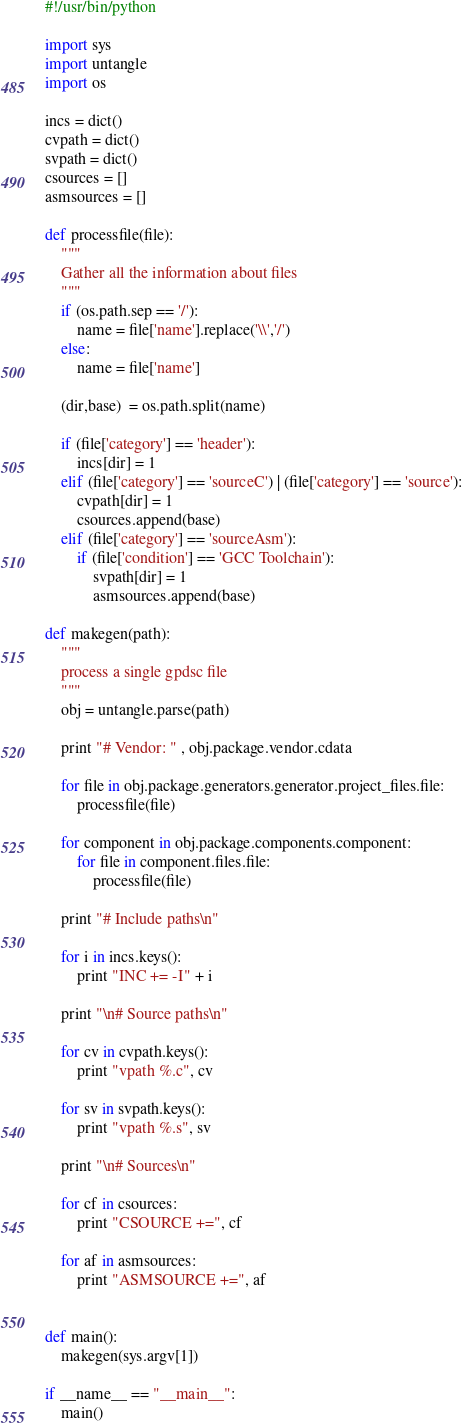Convert code to text. <code><loc_0><loc_0><loc_500><loc_500><_Python_>#!/usr/bin/python

import sys
import untangle
import os

incs = dict()
cvpath = dict()
svpath = dict()
csources = []
asmsources = []

def processfile(file):
    """
    Gather all the information about files
    """
    if (os.path.sep == '/'):
        name = file['name'].replace('\\','/')
    else:
        name = file['name']

    (dir,base)  = os.path.split(name)
    
    if (file['category'] == 'header'):
        incs[dir] = 1
    elif (file['category'] == 'sourceC') | (file['category'] == 'source'):
        cvpath[dir] = 1
        csources.append(base)
    elif (file['category'] == 'sourceAsm'):
        if (file['condition'] == 'GCC Toolchain'):
            svpath[dir] = 1
            asmsources.append(base)

def makegen(path):
    """
    process a single gpdsc file
    """
    obj = untangle.parse(path)

    print "# Vendor: " , obj.package.vendor.cdata

    for file in obj.package.generators.generator.project_files.file:
        processfile(file)

    for component in obj.package.components.component:
        for file in component.files.file:
            processfile(file)

    print "# Include paths\n"

    for i in incs.keys():
        print "INC += -I" + i

    print "\n# Source paths\n"

    for cv in cvpath.keys():
        print "vpath %.c", cv

    for sv in svpath.keys():
        print "vpath %.s", sv

    print "\n# Sources\n"

    for cf in csources:
        print "CSOURCE +=", cf

    for af in asmsources:
        print "ASMSOURCE +=", af


def main():
    makegen(sys.argv[1])

if __name__ == "__main__":
    main()
</code> 